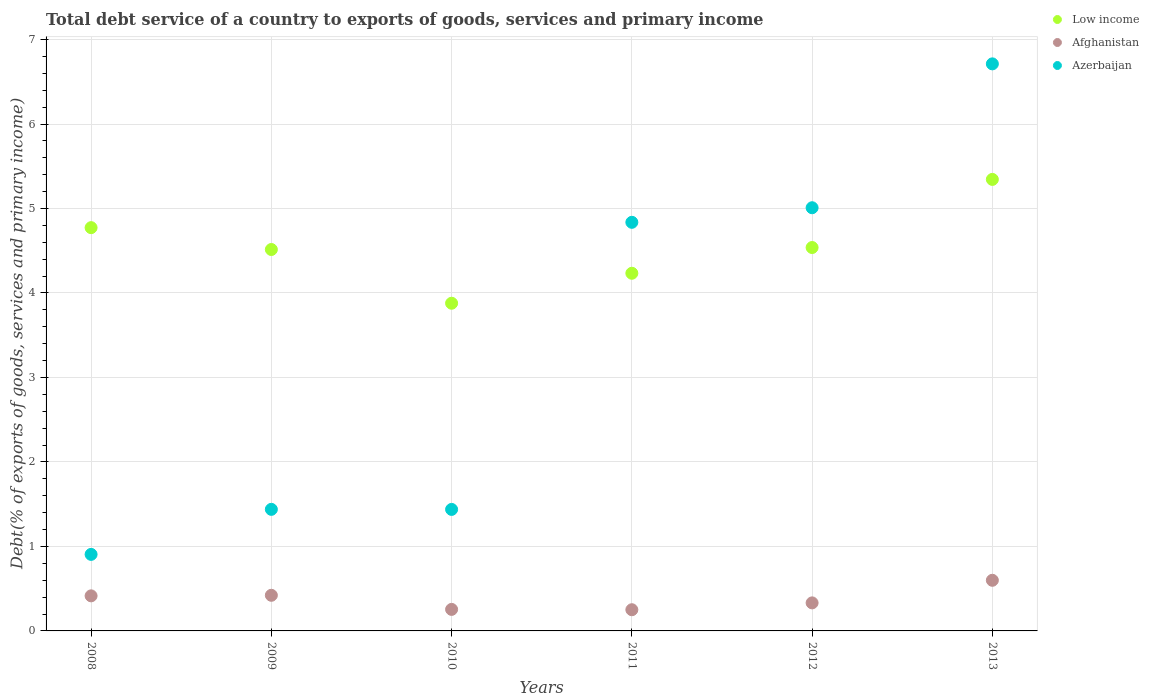Is the number of dotlines equal to the number of legend labels?
Offer a very short reply. Yes. What is the total debt service in Azerbaijan in 2013?
Your answer should be very brief. 6.71. Across all years, what is the maximum total debt service in Azerbaijan?
Provide a succinct answer. 6.71. Across all years, what is the minimum total debt service in Afghanistan?
Ensure brevity in your answer.  0.25. In which year was the total debt service in Azerbaijan maximum?
Provide a succinct answer. 2013. What is the total total debt service in Afghanistan in the graph?
Give a very brief answer. 2.27. What is the difference between the total debt service in Afghanistan in 2010 and that in 2012?
Provide a succinct answer. -0.08. What is the difference between the total debt service in Azerbaijan in 2013 and the total debt service in Low income in 2009?
Offer a very short reply. 2.2. What is the average total debt service in Afghanistan per year?
Keep it short and to the point. 0.38. In the year 2013, what is the difference between the total debt service in Afghanistan and total debt service in Azerbaijan?
Keep it short and to the point. -6.11. What is the ratio of the total debt service in Afghanistan in 2011 to that in 2012?
Give a very brief answer. 0.76. Is the total debt service in Azerbaijan in 2008 less than that in 2011?
Ensure brevity in your answer.  Yes. Is the difference between the total debt service in Afghanistan in 2008 and 2010 greater than the difference between the total debt service in Azerbaijan in 2008 and 2010?
Give a very brief answer. Yes. What is the difference between the highest and the second highest total debt service in Low income?
Provide a succinct answer. 0.57. What is the difference between the highest and the lowest total debt service in Low income?
Provide a succinct answer. 1.47. In how many years, is the total debt service in Low income greater than the average total debt service in Low income taken over all years?
Your response must be concise. 2. Does the total debt service in Low income monotonically increase over the years?
Keep it short and to the point. No. How many years are there in the graph?
Provide a short and direct response. 6. What is the difference between two consecutive major ticks on the Y-axis?
Make the answer very short. 1. Are the values on the major ticks of Y-axis written in scientific E-notation?
Make the answer very short. No. Does the graph contain any zero values?
Offer a terse response. No. Where does the legend appear in the graph?
Provide a succinct answer. Top right. How are the legend labels stacked?
Your answer should be compact. Vertical. What is the title of the graph?
Your answer should be very brief. Total debt service of a country to exports of goods, services and primary income. Does "Belize" appear as one of the legend labels in the graph?
Your answer should be compact. No. What is the label or title of the X-axis?
Offer a very short reply. Years. What is the label or title of the Y-axis?
Offer a terse response. Debt(% of exports of goods, services and primary income). What is the Debt(% of exports of goods, services and primary income) in Low income in 2008?
Keep it short and to the point. 4.77. What is the Debt(% of exports of goods, services and primary income) of Afghanistan in 2008?
Make the answer very short. 0.42. What is the Debt(% of exports of goods, services and primary income) in Azerbaijan in 2008?
Offer a terse response. 0.91. What is the Debt(% of exports of goods, services and primary income) of Low income in 2009?
Your answer should be compact. 4.51. What is the Debt(% of exports of goods, services and primary income) of Afghanistan in 2009?
Offer a very short reply. 0.42. What is the Debt(% of exports of goods, services and primary income) of Azerbaijan in 2009?
Give a very brief answer. 1.44. What is the Debt(% of exports of goods, services and primary income) of Low income in 2010?
Offer a terse response. 3.88. What is the Debt(% of exports of goods, services and primary income) of Afghanistan in 2010?
Give a very brief answer. 0.25. What is the Debt(% of exports of goods, services and primary income) of Azerbaijan in 2010?
Provide a succinct answer. 1.44. What is the Debt(% of exports of goods, services and primary income) of Low income in 2011?
Offer a very short reply. 4.23. What is the Debt(% of exports of goods, services and primary income) in Afghanistan in 2011?
Provide a succinct answer. 0.25. What is the Debt(% of exports of goods, services and primary income) of Azerbaijan in 2011?
Your answer should be compact. 4.84. What is the Debt(% of exports of goods, services and primary income) of Low income in 2012?
Keep it short and to the point. 4.54. What is the Debt(% of exports of goods, services and primary income) in Afghanistan in 2012?
Ensure brevity in your answer.  0.33. What is the Debt(% of exports of goods, services and primary income) of Azerbaijan in 2012?
Offer a terse response. 5.01. What is the Debt(% of exports of goods, services and primary income) of Low income in 2013?
Ensure brevity in your answer.  5.34. What is the Debt(% of exports of goods, services and primary income) in Afghanistan in 2013?
Your answer should be very brief. 0.6. What is the Debt(% of exports of goods, services and primary income) of Azerbaijan in 2013?
Your response must be concise. 6.71. Across all years, what is the maximum Debt(% of exports of goods, services and primary income) in Low income?
Keep it short and to the point. 5.34. Across all years, what is the maximum Debt(% of exports of goods, services and primary income) in Afghanistan?
Ensure brevity in your answer.  0.6. Across all years, what is the maximum Debt(% of exports of goods, services and primary income) in Azerbaijan?
Make the answer very short. 6.71. Across all years, what is the minimum Debt(% of exports of goods, services and primary income) of Low income?
Your response must be concise. 3.88. Across all years, what is the minimum Debt(% of exports of goods, services and primary income) in Afghanistan?
Your answer should be compact. 0.25. Across all years, what is the minimum Debt(% of exports of goods, services and primary income) in Azerbaijan?
Give a very brief answer. 0.91. What is the total Debt(% of exports of goods, services and primary income) in Low income in the graph?
Your answer should be very brief. 27.28. What is the total Debt(% of exports of goods, services and primary income) of Afghanistan in the graph?
Your response must be concise. 2.27. What is the total Debt(% of exports of goods, services and primary income) of Azerbaijan in the graph?
Provide a succinct answer. 20.34. What is the difference between the Debt(% of exports of goods, services and primary income) in Low income in 2008 and that in 2009?
Provide a short and direct response. 0.26. What is the difference between the Debt(% of exports of goods, services and primary income) of Afghanistan in 2008 and that in 2009?
Your answer should be very brief. -0.01. What is the difference between the Debt(% of exports of goods, services and primary income) of Azerbaijan in 2008 and that in 2009?
Offer a terse response. -0.53. What is the difference between the Debt(% of exports of goods, services and primary income) of Low income in 2008 and that in 2010?
Offer a terse response. 0.89. What is the difference between the Debt(% of exports of goods, services and primary income) in Afghanistan in 2008 and that in 2010?
Provide a short and direct response. 0.16. What is the difference between the Debt(% of exports of goods, services and primary income) in Azerbaijan in 2008 and that in 2010?
Provide a succinct answer. -0.53. What is the difference between the Debt(% of exports of goods, services and primary income) in Low income in 2008 and that in 2011?
Your answer should be compact. 0.54. What is the difference between the Debt(% of exports of goods, services and primary income) in Afghanistan in 2008 and that in 2011?
Provide a succinct answer. 0.16. What is the difference between the Debt(% of exports of goods, services and primary income) in Azerbaijan in 2008 and that in 2011?
Offer a very short reply. -3.93. What is the difference between the Debt(% of exports of goods, services and primary income) of Low income in 2008 and that in 2012?
Offer a very short reply. 0.24. What is the difference between the Debt(% of exports of goods, services and primary income) in Afghanistan in 2008 and that in 2012?
Make the answer very short. 0.08. What is the difference between the Debt(% of exports of goods, services and primary income) of Azerbaijan in 2008 and that in 2012?
Make the answer very short. -4.1. What is the difference between the Debt(% of exports of goods, services and primary income) in Low income in 2008 and that in 2013?
Provide a succinct answer. -0.57. What is the difference between the Debt(% of exports of goods, services and primary income) of Afghanistan in 2008 and that in 2013?
Your answer should be compact. -0.18. What is the difference between the Debt(% of exports of goods, services and primary income) of Azerbaijan in 2008 and that in 2013?
Keep it short and to the point. -5.81. What is the difference between the Debt(% of exports of goods, services and primary income) in Low income in 2009 and that in 2010?
Offer a very short reply. 0.64. What is the difference between the Debt(% of exports of goods, services and primary income) of Afghanistan in 2009 and that in 2010?
Give a very brief answer. 0.17. What is the difference between the Debt(% of exports of goods, services and primary income) of Azerbaijan in 2009 and that in 2010?
Ensure brevity in your answer.  0. What is the difference between the Debt(% of exports of goods, services and primary income) in Low income in 2009 and that in 2011?
Your response must be concise. 0.28. What is the difference between the Debt(% of exports of goods, services and primary income) of Afghanistan in 2009 and that in 2011?
Provide a short and direct response. 0.17. What is the difference between the Debt(% of exports of goods, services and primary income) in Azerbaijan in 2009 and that in 2011?
Offer a very short reply. -3.4. What is the difference between the Debt(% of exports of goods, services and primary income) in Low income in 2009 and that in 2012?
Provide a succinct answer. -0.02. What is the difference between the Debt(% of exports of goods, services and primary income) of Afghanistan in 2009 and that in 2012?
Keep it short and to the point. 0.09. What is the difference between the Debt(% of exports of goods, services and primary income) of Azerbaijan in 2009 and that in 2012?
Offer a very short reply. -3.57. What is the difference between the Debt(% of exports of goods, services and primary income) of Low income in 2009 and that in 2013?
Make the answer very short. -0.83. What is the difference between the Debt(% of exports of goods, services and primary income) in Afghanistan in 2009 and that in 2013?
Your answer should be compact. -0.18. What is the difference between the Debt(% of exports of goods, services and primary income) of Azerbaijan in 2009 and that in 2013?
Provide a short and direct response. -5.27. What is the difference between the Debt(% of exports of goods, services and primary income) of Low income in 2010 and that in 2011?
Provide a succinct answer. -0.35. What is the difference between the Debt(% of exports of goods, services and primary income) of Afghanistan in 2010 and that in 2011?
Your response must be concise. 0. What is the difference between the Debt(% of exports of goods, services and primary income) in Azerbaijan in 2010 and that in 2011?
Keep it short and to the point. -3.4. What is the difference between the Debt(% of exports of goods, services and primary income) in Low income in 2010 and that in 2012?
Provide a succinct answer. -0.66. What is the difference between the Debt(% of exports of goods, services and primary income) of Afghanistan in 2010 and that in 2012?
Ensure brevity in your answer.  -0.08. What is the difference between the Debt(% of exports of goods, services and primary income) of Azerbaijan in 2010 and that in 2012?
Your response must be concise. -3.57. What is the difference between the Debt(% of exports of goods, services and primary income) in Low income in 2010 and that in 2013?
Your answer should be very brief. -1.47. What is the difference between the Debt(% of exports of goods, services and primary income) in Afghanistan in 2010 and that in 2013?
Give a very brief answer. -0.34. What is the difference between the Debt(% of exports of goods, services and primary income) of Azerbaijan in 2010 and that in 2013?
Offer a very short reply. -5.27. What is the difference between the Debt(% of exports of goods, services and primary income) of Low income in 2011 and that in 2012?
Your answer should be very brief. -0.3. What is the difference between the Debt(% of exports of goods, services and primary income) in Afghanistan in 2011 and that in 2012?
Keep it short and to the point. -0.08. What is the difference between the Debt(% of exports of goods, services and primary income) of Azerbaijan in 2011 and that in 2012?
Offer a terse response. -0.17. What is the difference between the Debt(% of exports of goods, services and primary income) of Low income in 2011 and that in 2013?
Your answer should be compact. -1.11. What is the difference between the Debt(% of exports of goods, services and primary income) in Afghanistan in 2011 and that in 2013?
Your response must be concise. -0.35. What is the difference between the Debt(% of exports of goods, services and primary income) of Azerbaijan in 2011 and that in 2013?
Ensure brevity in your answer.  -1.88. What is the difference between the Debt(% of exports of goods, services and primary income) of Low income in 2012 and that in 2013?
Provide a short and direct response. -0.81. What is the difference between the Debt(% of exports of goods, services and primary income) in Afghanistan in 2012 and that in 2013?
Give a very brief answer. -0.27. What is the difference between the Debt(% of exports of goods, services and primary income) of Azerbaijan in 2012 and that in 2013?
Offer a terse response. -1.7. What is the difference between the Debt(% of exports of goods, services and primary income) in Low income in 2008 and the Debt(% of exports of goods, services and primary income) in Afghanistan in 2009?
Provide a succinct answer. 4.35. What is the difference between the Debt(% of exports of goods, services and primary income) of Low income in 2008 and the Debt(% of exports of goods, services and primary income) of Azerbaijan in 2009?
Offer a terse response. 3.33. What is the difference between the Debt(% of exports of goods, services and primary income) in Afghanistan in 2008 and the Debt(% of exports of goods, services and primary income) in Azerbaijan in 2009?
Offer a terse response. -1.02. What is the difference between the Debt(% of exports of goods, services and primary income) of Low income in 2008 and the Debt(% of exports of goods, services and primary income) of Afghanistan in 2010?
Give a very brief answer. 4.52. What is the difference between the Debt(% of exports of goods, services and primary income) in Low income in 2008 and the Debt(% of exports of goods, services and primary income) in Azerbaijan in 2010?
Give a very brief answer. 3.34. What is the difference between the Debt(% of exports of goods, services and primary income) of Afghanistan in 2008 and the Debt(% of exports of goods, services and primary income) of Azerbaijan in 2010?
Give a very brief answer. -1.02. What is the difference between the Debt(% of exports of goods, services and primary income) of Low income in 2008 and the Debt(% of exports of goods, services and primary income) of Afghanistan in 2011?
Your answer should be very brief. 4.52. What is the difference between the Debt(% of exports of goods, services and primary income) in Low income in 2008 and the Debt(% of exports of goods, services and primary income) in Azerbaijan in 2011?
Your answer should be compact. -0.06. What is the difference between the Debt(% of exports of goods, services and primary income) of Afghanistan in 2008 and the Debt(% of exports of goods, services and primary income) of Azerbaijan in 2011?
Your response must be concise. -4.42. What is the difference between the Debt(% of exports of goods, services and primary income) of Low income in 2008 and the Debt(% of exports of goods, services and primary income) of Afghanistan in 2012?
Your answer should be very brief. 4.44. What is the difference between the Debt(% of exports of goods, services and primary income) of Low income in 2008 and the Debt(% of exports of goods, services and primary income) of Azerbaijan in 2012?
Provide a short and direct response. -0.24. What is the difference between the Debt(% of exports of goods, services and primary income) in Afghanistan in 2008 and the Debt(% of exports of goods, services and primary income) in Azerbaijan in 2012?
Provide a short and direct response. -4.59. What is the difference between the Debt(% of exports of goods, services and primary income) of Low income in 2008 and the Debt(% of exports of goods, services and primary income) of Afghanistan in 2013?
Ensure brevity in your answer.  4.17. What is the difference between the Debt(% of exports of goods, services and primary income) of Low income in 2008 and the Debt(% of exports of goods, services and primary income) of Azerbaijan in 2013?
Your answer should be very brief. -1.94. What is the difference between the Debt(% of exports of goods, services and primary income) in Afghanistan in 2008 and the Debt(% of exports of goods, services and primary income) in Azerbaijan in 2013?
Provide a succinct answer. -6.3. What is the difference between the Debt(% of exports of goods, services and primary income) of Low income in 2009 and the Debt(% of exports of goods, services and primary income) of Afghanistan in 2010?
Give a very brief answer. 4.26. What is the difference between the Debt(% of exports of goods, services and primary income) in Low income in 2009 and the Debt(% of exports of goods, services and primary income) in Azerbaijan in 2010?
Ensure brevity in your answer.  3.08. What is the difference between the Debt(% of exports of goods, services and primary income) of Afghanistan in 2009 and the Debt(% of exports of goods, services and primary income) of Azerbaijan in 2010?
Make the answer very short. -1.02. What is the difference between the Debt(% of exports of goods, services and primary income) of Low income in 2009 and the Debt(% of exports of goods, services and primary income) of Afghanistan in 2011?
Keep it short and to the point. 4.26. What is the difference between the Debt(% of exports of goods, services and primary income) in Low income in 2009 and the Debt(% of exports of goods, services and primary income) in Azerbaijan in 2011?
Make the answer very short. -0.32. What is the difference between the Debt(% of exports of goods, services and primary income) of Afghanistan in 2009 and the Debt(% of exports of goods, services and primary income) of Azerbaijan in 2011?
Your response must be concise. -4.42. What is the difference between the Debt(% of exports of goods, services and primary income) of Low income in 2009 and the Debt(% of exports of goods, services and primary income) of Afghanistan in 2012?
Ensure brevity in your answer.  4.18. What is the difference between the Debt(% of exports of goods, services and primary income) in Low income in 2009 and the Debt(% of exports of goods, services and primary income) in Azerbaijan in 2012?
Provide a short and direct response. -0.49. What is the difference between the Debt(% of exports of goods, services and primary income) in Afghanistan in 2009 and the Debt(% of exports of goods, services and primary income) in Azerbaijan in 2012?
Make the answer very short. -4.59. What is the difference between the Debt(% of exports of goods, services and primary income) in Low income in 2009 and the Debt(% of exports of goods, services and primary income) in Afghanistan in 2013?
Your answer should be compact. 3.92. What is the difference between the Debt(% of exports of goods, services and primary income) of Low income in 2009 and the Debt(% of exports of goods, services and primary income) of Azerbaijan in 2013?
Your answer should be compact. -2.2. What is the difference between the Debt(% of exports of goods, services and primary income) of Afghanistan in 2009 and the Debt(% of exports of goods, services and primary income) of Azerbaijan in 2013?
Provide a short and direct response. -6.29. What is the difference between the Debt(% of exports of goods, services and primary income) in Low income in 2010 and the Debt(% of exports of goods, services and primary income) in Afghanistan in 2011?
Your answer should be very brief. 3.63. What is the difference between the Debt(% of exports of goods, services and primary income) of Low income in 2010 and the Debt(% of exports of goods, services and primary income) of Azerbaijan in 2011?
Give a very brief answer. -0.96. What is the difference between the Debt(% of exports of goods, services and primary income) in Afghanistan in 2010 and the Debt(% of exports of goods, services and primary income) in Azerbaijan in 2011?
Provide a succinct answer. -4.58. What is the difference between the Debt(% of exports of goods, services and primary income) of Low income in 2010 and the Debt(% of exports of goods, services and primary income) of Afghanistan in 2012?
Your answer should be compact. 3.55. What is the difference between the Debt(% of exports of goods, services and primary income) of Low income in 2010 and the Debt(% of exports of goods, services and primary income) of Azerbaijan in 2012?
Offer a terse response. -1.13. What is the difference between the Debt(% of exports of goods, services and primary income) in Afghanistan in 2010 and the Debt(% of exports of goods, services and primary income) in Azerbaijan in 2012?
Keep it short and to the point. -4.75. What is the difference between the Debt(% of exports of goods, services and primary income) of Low income in 2010 and the Debt(% of exports of goods, services and primary income) of Afghanistan in 2013?
Give a very brief answer. 3.28. What is the difference between the Debt(% of exports of goods, services and primary income) in Low income in 2010 and the Debt(% of exports of goods, services and primary income) in Azerbaijan in 2013?
Your response must be concise. -2.83. What is the difference between the Debt(% of exports of goods, services and primary income) of Afghanistan in 2010 and the Debt(% of exports of goods, services and primary income) of Azerbaijan in 2013?
Give a very brief answer. -6.46. What is the difference between the Debt(% of exports of goods, services and primary income) in Low income in 2011 and the Debt(% of exports of goods, services and primary income) in Afghanistan in 2012?
Give a very brief answer. 3.9. What is the difference between the Debt(% of exports of goods, services and primary income) in Low income in 2011 and the Debt(% of exports of goods, services and primary income) in Azerbaijan in 2012?
Your response must be concise. -0.78. What is the difference between the Debt(% of exports of goods, services and primary income) in Afghanistan in 2011 and the Debt(% of exports of goods, services and primary income) in Azerbaijan in 2012?
Your response must be concise. -4.76. What is the difference between the Debt(% of exports of goods, services and primary income) of Low income in 2011 and the Debt(% of exports of goods, services and primary income) of Afghanistan in 2013?
Provide a succinct answer. 3.63. What is the difference between the Debt(% of exports of goods, services and primary income) of Low income in 2011 and the Debt(% of exports of goods, services and primary income) of Azerbaijan in 2013?
Give a very brief answer. -2.48. What is the difference between the Debt(% of exports of goods, services and primary income) in Afghanistan in 2011 and the Debt(% of exports of goods, services and primary income) in Azerbaijan in 2013?
Provide a short and direct response. -6.46. What is the difference between the Debt(% of exports of goods, services and primary income) in Low income in 2012 and the Debt(% of exports of goods, services and primary income) in Afghanistan in 2013?
Offer a terse response. 3.94. What is the difference between the Debt(% of exports of goods, services and primary income) of Low income in 2012 and the Debt(% of exports of goods, services and primary income) of Azerbaijan in 2013?
Your response must be concise. -2.17. What is the difference between the Debt(% of exports of goods, services and primary income) of Afghanistan in 2012 and the Debt(% of exports of goods, services and primary income) of Azerbaijan in 2013?
Give a very brief answer. -6.38. What is the average Debt(% of exports of goods, services and primary income) in Low income per year?
Your answer should be very brief. 4.55. What is the average Debt(% of exports of goods, services and primary income) in Afghanistan per year?
Make the answer very short. 0.38. What is the average Debt(% of exports of goods, services and primary income) in Azerbaijan per year?
Provide a succinct answer. 3.39. In the year 2008, what is the difference between the Debt(% of exports of goods, services and primary income) in Low income and Debt(% of exports of goods, services and primary income) in Afghanistan?
Offer a terse response. 4.36. In the year 2008, what is the difference between the Debt(% of exports of goods, services and primary income) of Low income and Debt(% of exports of goods, services and primary income) of Azerbaijan?
Your answer should be very brief. 3.87. In the year 2008, what is the difference between the Debt(% of exports of goods, services and primary income) of Afghanistan and Debt(% of exports of goods, services and primary income) of Azerbaijan?
Offer a very short reply. -0.49. In the year 2009, what is the difference between the Debt(% of exports of goods, services and primary income) of Low income and Debt(% of exports of goods, services and primary income) of Afghanistan?
Your response must be concise. 4.09. In the year 2009, what is the difference between the Debt(% of exports of goods, services and primary income) of Low income and Debt(% of exports of goods, services and primary income) of Azerbaijan?
Make the answer very short. 3.08. In the year 2009, what is the difference between the Debt(% of exports of goods, services and primary income) of Afghanistan and Debt(% of exports of goods, services and primary income) of Azerbaijan?
Provide a succinct answer. -1.02. In the year 2010, what is the difference between the Debt(% of exports of goods, services and primary income) of Low income and Debt(% of exports of goods, services and primary income) of Afghanistan?
Give a very brief answer. 3.62. In the year 2010, what is the difference between the Debt(% of exports of goods, services and primary income) in Low income and Debt(% of exports of goods, services and primary income) in Azerbaijan?
Your answer should be very brief. 2.44. In the year 2010, what is the difference between the Debt(% of exports of goods, services and primary income) of Afghanistan and Debt(% of exports of goods, services and primary income) of Azerbaijan?
Keep it short and to the point. -1.18. In the year 2011, what is the difference between the Debt(% of exports of goods, services and primary income) in Low income and Debt(% of exports of goods, services and primary income) in Afghanistan?
Give a very brief answer. 3.98. In the year 2011, what is the difference between the Debt(% of exports of goods, services and primary income) in Low income and Debt(% of exports of goods, services and primary income) in Azerbaijan?
Your response must be concise. -0.6. In the year 2011, what is the difference between the Debt(% of exports of goods, services and primary income) of Afghanistan and Debt(% of exports of goods, services and primary income) of Azerbaijan?
Keep it short and to the point. -4.59. In the year 2012, what is the difference between the Debt(% of exports of goods, services and primary income) of Low income and Debt(% of exports of goods, services and primary income) of Afghanistan?
Your answer should be compact. 4.21. In the year 2012, what is the difference between the Debt(% of exports of goods, services and primary income) in Low income and Debt(% of exports of goods, services and primary income) in Azerbaijan?
Keep it short and to the point. -0.47. In the year 2012, what is the difference between the Debt(% of exports of goods, services and primary income) in Afghanistan and Debt(% of exports of goods, services and primary income) in Azerbaijan?
Your answer should be very brief. -4.68. In the year 2013, what is the difference between the Debt(% of exports of goods, services and primary income) of Low income and Debt(% of exports of goods, services and primary income) of Afghanistan?
Provide a short and direct response. 4.75. In the year 2013, what is the difference between the Debt(% of exports of goods, services and primary income) in Low income and Debt(% of exports of goods, services and primary income) in Azerbaijan?
Offer a very short reply. -1.37. In the year 2013, what is the difference between the Debt(% of exports of goods, services and primary income) of Afghanistan and Debt(% of exports of goods, services and primary income) of Azerbaijan?
Keep it short and to the point. -6.11. What is the ratio of the Debt(% of exports of goods, services and primary income) of Low income in 2008 to that in 2009?
Offer a terse response. 1.06. What is the ratio of the Debt(% of exports of goods, services and primary income) in Afghanistan in 2008 to that in 2009?
Your answer should be very brief. 0.98. What is the ratio of the Debt(% of exports of goods, services and primary income) in Azerbaijan in 2008 to that in 2009?
Give a very brief answer. 0.63. What is the ratio of the Debt(% of exports of goods, services and primary income) of Low income in 2008 to that in 2010?
Your answer should be compact. 1.23. What is the ratio of the Debt(% of exports of goods, services and primary income) in Afghanistan in 2008 to that in 2010?
Your answer should be very brief. 1.63. What is the ratio of the Debt(% of exports of goods, services and primary income) in Azerbaijan in 2008 to that in 2010?
Offer a very short reply. 0.63. What is the ratio of the Debt(% of exports of goods, services and primary income) of Low income in 2008 to that in 2011?
Your response must be concise. 1.13. What is the ratio of the Debt(% of exports of goods, services and primary income) in Afghanistan in 2008 to that in 2011?
Your answer should be very brief. 1.65. What is the ratio of the Debt(% of exports of goods, services and primary income) of Azerbaijan in 2008 to that in 2011?
Offer a very short reply. 0.19. What is the ratio of the Debt(% of exports of goods, services and primary income) of Low income in 2008 to that in 2012?
Provide a short and direct response. 1.05. What is the ratio of the Debt(% of exports of goods, services and primary income) in Afghanistan in 2008 to that in 2012?
Offer a very short reply. 1.25. What is the ratio of the Debt(% of exports of goods, services and primary income) in Azerbaijan in 2008 to that in 2012?
Make the answer very short. 0.18. What is the ratio of the Debt(% of exports of goods, services and primary income) of Low income in 2008 to that in 2013?
Your response must be concise. 0.89. What is the ratio of the Debt(% of exports of goods, services and primary income) in Afghanistan in 2008 to that in 2013?
Give a very brief answer. 0.69. What is the ratio of the Debt(% of exports of goods, services and primary income) in Azerbaijan in 2008 to that in 2013?
Make the answer very short. 0.14. What is the ratio of the Debt(% of exports of goods, services and primary income) of Low income in 2009 to that in 2010?
Make the answer very short. 1.16. What is the ratio of the Debt(% of exports of goods, services and primary income) in Afghanistan in 2009 to that in 2010?
Your answer should be very brief. 1.65. What is the ratio of the Debt(% of exports of goods, services and primary income) in Azerbaijan in 2009 to that in 2010?
Give a very brief answer. 1. What is the ratio of the Debt(% of exports of goods, services and primary income) in Low income in 2009 to that in 2011?
Your answer should be very brief. 1.07. What is the ratio of the Debt(% of exports of goods, services and primary income) in Afghanistan in 2009 to that in 2011?
Provide a short and direct response. 1.68. What is the ratio of the Debt(% of exports of goods, services and primary income) of Azerbaijan in 2009 to that in 2011?
Your answer should be very brief. 0.3. What is the ratio of the Debt(% of exports of goods, services and primary income) of Low income in 2009 to that in 2012?
Your answer should be very brief. 0.99. What is the ratio of the Debt(% of exports of goods, services and primary income) in Afghanistan in 2009 to that in 2012?
Offer a terse response. 1.27. What is the ratio of the Debt(% of exports of goods, services and primary income) of Azerbaijan in 2009 to that in 2012?
Provide a short and direct response. 0.29. What is the ratio of the Debt(% of exports of goods, services and primary income) of Low income in 2009 to that in 2013?
Ensure brevity in your answer.  0.84. What is the ratio of the Debt(% of exports of goods, services and primary income) of Afghanistan in 2009 to that in 2013?
Your answer should be very brief. 0.7. What is the ratio of the Debt(% of exports of goods, services and primary income) of Azerbaijan in 2009 to that in 2013?
Your answer should be compact. 0.21. What is the ratio of the Debt(% of exports of goods, services and primary income) of Low income in 2010 to that in 2011?
Your answer should be compact. 0.92. What is the ratio of the Debt(% of exports of goods, services and primary income) in Afghanistan in 2010 to that in 2011?
Your response must be concise. 1.02. What is the ratio of the Debt(% of exports of goods, services and primary income) in Azerbaijan in 2010 to that in 2011?
Offer a terse response. 0.3. What is the ratio of the Debt(% of exports of goods, services and primary income) of Low income in 2010 to that in 2012?
Your answer should be compact. 0.85. What is the ratio of the Debt(% of exports of goods, services and primary income) in Afghanistan in 2010 to that in 2012?
Your answer should be compact. 0.77. What is the ratio of the Debt(% of exports of goods, services and primary income) of Azerbaijan in 2010 to that in 2012?
Offer a very short reply. 0.29. What is the ratio of the Debt(% of exports of goods, services and primary income) of Low income in 2010 to that in 2013?
Provide a short and direct response. 0.73. What is the ratio of the Debt(% of exports of goods, services and primary income) in Afghanistan in 2010 to that in 2013?
Your response must be concise. 0.43. What is the ratio of the Debt(% of exports of goods, services and primary income) in Azerbaijan in 2010 to that in 2013?
Make the answer very short. 0.21. What is the ratio of the Debt(% of exports of goods, services and primary income) in Low income in 2011 to that in 2012?
Provide a succinct answer. 0.93. What is the ratio of the Debt(% of exports of goods, services and primary income) of Afghanistan in 2011 to that in 2012?
Keep it short and to the point. 0.76. What is the ratio of the Debt(% of exports of goods, services and primary income) in Azerbaijan in 2011 to that in 2012?
Your answer should be compact. 0.97. What is the ratio of the Debt(% of exports of goods, services and primary income) of Low income in 2011 to that in 2013?
Make the answer very short. 0.79. What is the ratio of the Debt(% of exports of goods, services and primary income) of Afghanistan in 2011 to that in 2013?
Your response must be concise. 0.42. What is the ratio of the Debt(% of exports of goods, services and primary income) of Azerbaijan in 2011 to that in 2013?
Your answer should be very brief. 0.72. What is the ratio of the Debt(% of exports of goods, services and primary income) in Low income in 2012 to that in 2013?
Your response must be concise. 0.85. What is the ratio of the Debt(% of exports of goods, services and primary income) in Afghanistan in 2012 to that in 2013?
Ensure brevity in your answer.  0.55. What is the ratio of the Debt(% of exports of goods, services and primary income) of Azerbaijan in 2012 to that in 2013?
Ensure brevity in your answer.  0.75. What is the difference between the highest and the second highest Debt(% of exports of goods, services and primary income) in Low income?
Keep it short and to the point. 0.57. What is the difference between the highest and the second highest Debt(% of exports of goods, services and primary income) of Afghanistan?
Ensure brevity in your answer.  0.18. What is the difference between the highest and the second highest Debt(% of exports of goods, services and primary income) in Azerbaijan?
Offer a very short reply. 1.7. What is the difference between the highest and the lowest Debt(% of exports of goods, services and primary income) of Low income?
Provide a succinct answer. 1.47. What is the difference between the highest and the lowest Debt(% of exports of goods, services and primary income) of Afghanistan?
Offer a very short reply. 0.35. What is the difference between the highest and the lowest Debt(% of exports of goods, services and primary income) of Azerbaijan?
Ensure brevity in your answer.  5.81. 